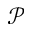Convert formula to latex. <formula><loc_0><loc_0><loc_500><loc_500>\mathcal { P }</formula> 